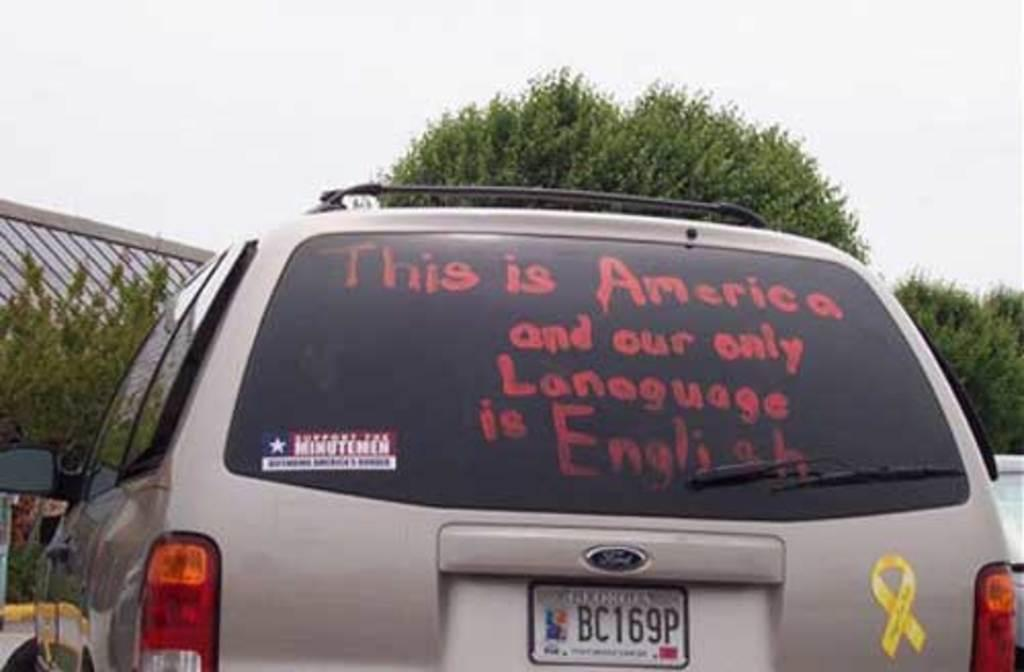<image>
Summarize the visual content of the image. An suv with a yellow ribbon on it says that the only language in America is English. 